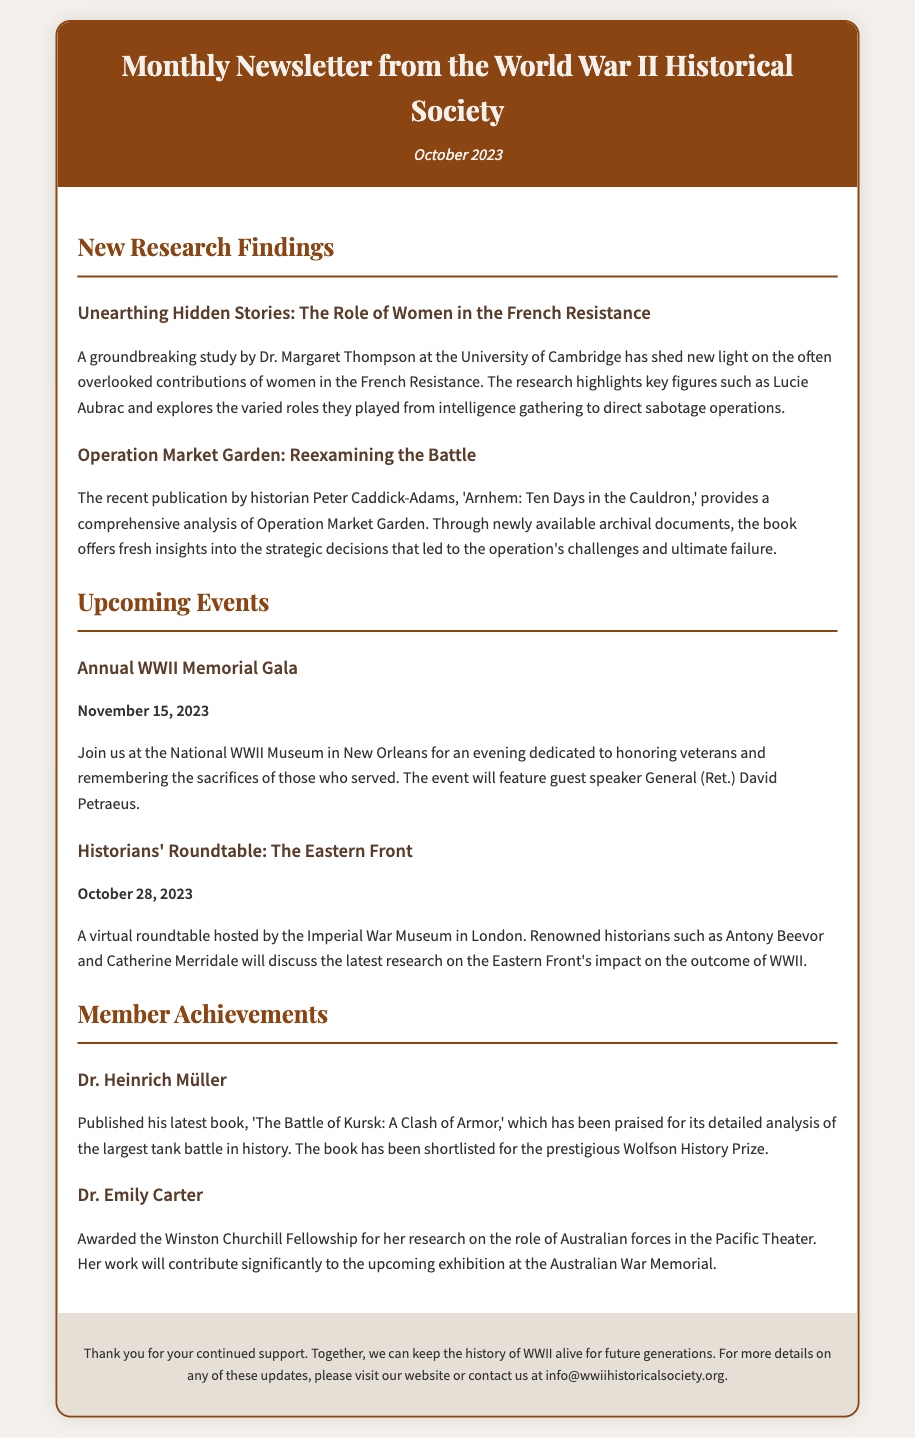What is the title of the newsletter? The title of the newsletter is found in the header section, stating the purpose and organization.
Answer: Monthly Newsletter from the World War II Historical Society Who conducted the study on the role of women in the French Resistance? The document mentions a specific researcher credited with the groundbreaking study in the new research findings section.
Answer: Dr. Margaret Thompson What is the date of the Annual WWII Memorial Gala? This information is provided under the upcoming events section, specifically about the gala event.
Answer: November 15, 2023 Which historian's book reexamines Operation Market Garden? The document references a specific historian and their recent publication related to Operation Market Garden.
Answer: Peter Caddick-Adams What fellowship was awarded to Dr. Emily Carter? This detail is specified in the member achievements section, highlighting a particular fellowship received by Dr. Emily Carter.
Answer: Winston Churchill Fellowship How many historians are mentioned in the virtual roundtable event? The document lists historians participating in an upcoming event, requiring counting mentioned individuals.
Answer: Two Which battle does Dr. Heinrich Müller focus on in his latest book? The document includes specifics about Dr. Heinrich Müller's published work, indicating the central topic of the book.
Answer: The Battle of Kursk What is the primary goal of the WWII Historical Society as conveyed in the footer? This is a summarizing statement that reflects the overarching mission or vision of the organization.
Answer: Keep the history of WWII alive for future generations 